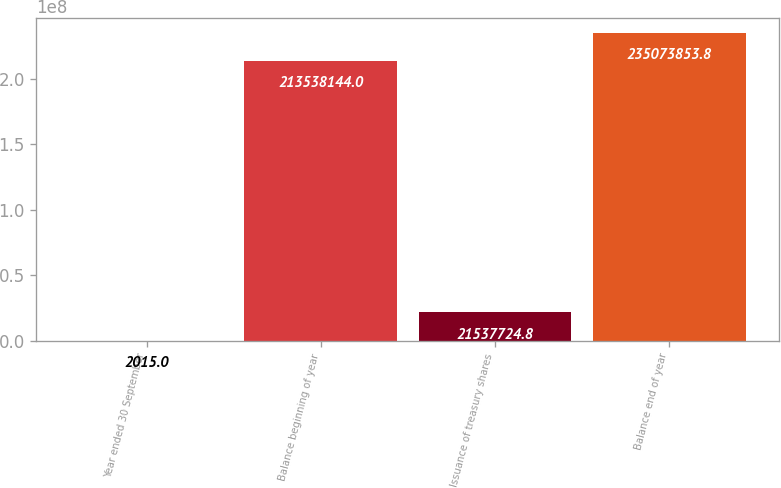Convert chart to OTSL. <chart><loc_0><loc_0><loc_500><loc_500><bar_chart><fcel>Year ended 30 September<fcel>Balance beginning of year<fcel>Issuance of treasury shares<fcel>Balance end of year<nl><fcel>2015<fcel>2.13538e+08<fcel>2.15377e+07<fcel>2.35074e+08<nl></chart> 